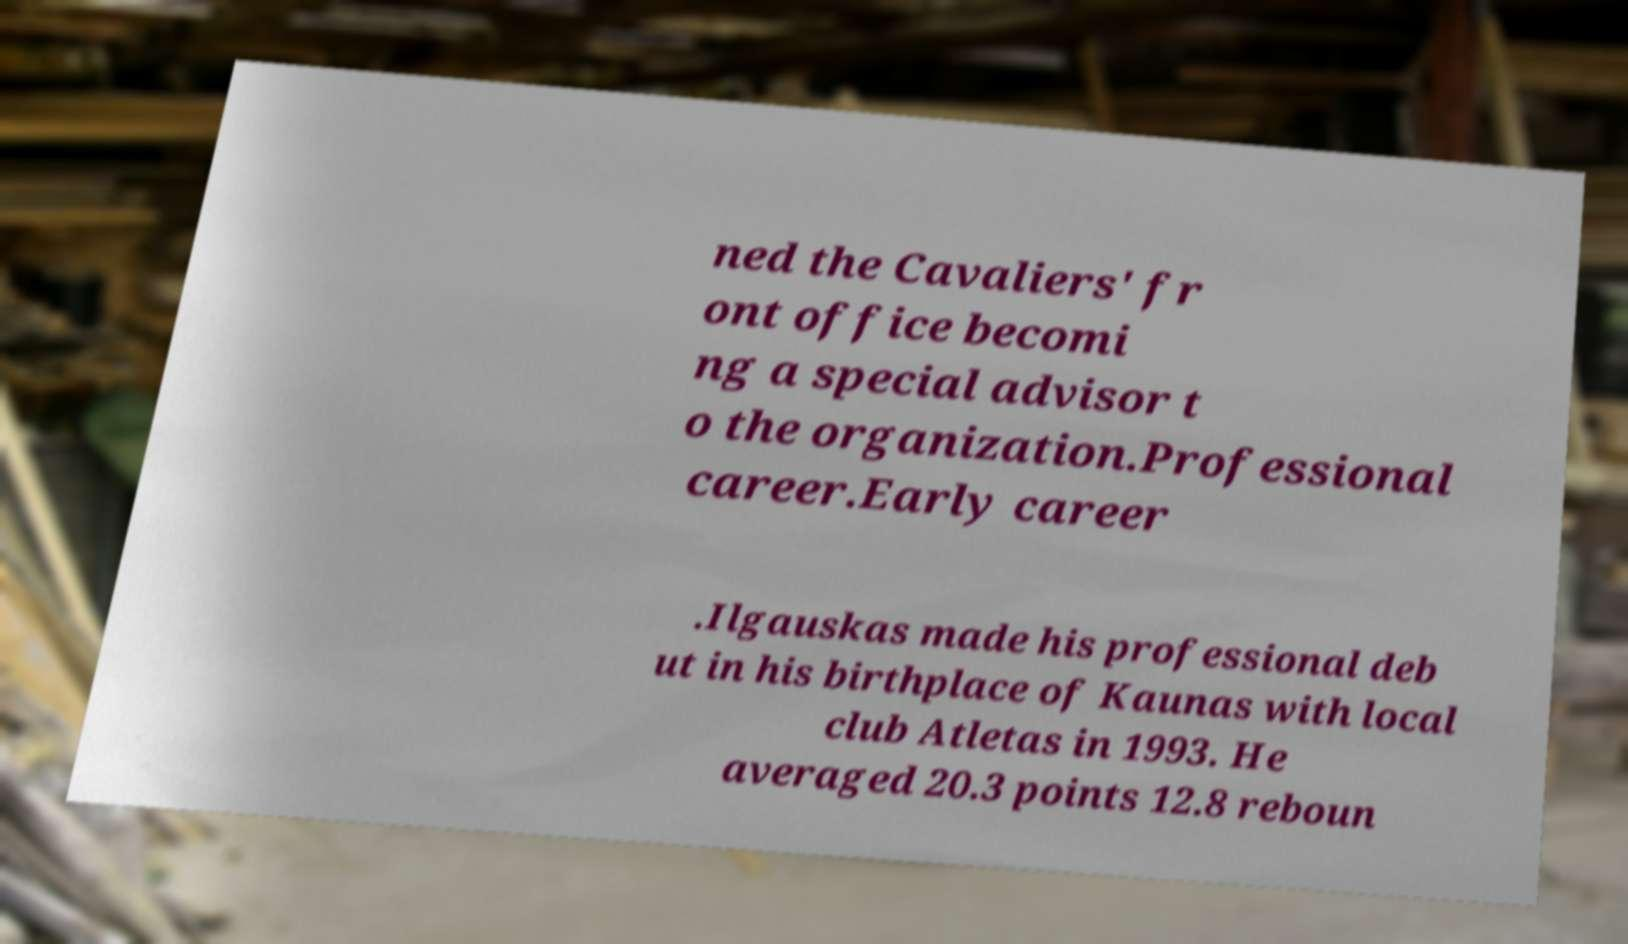What messages or text are displayed in this image? I need them in a readable, typed format. ned the Cavaliers' fr ont office becomi ng a special advisor t o the organization.Professional career.Early career .Ilgauskas made his professional deb ut in his birthplace of Kaunas with local club Atletas in 1993. He averaged 20.3 points 12.8 reboun 